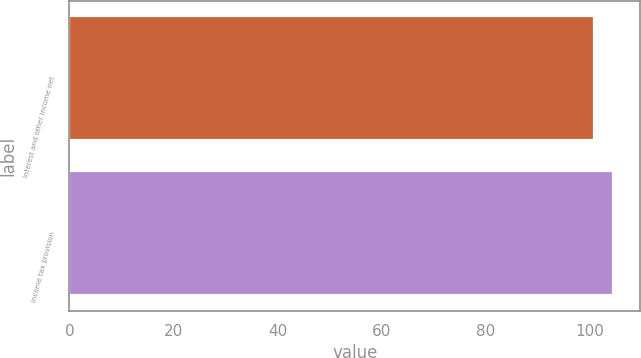Convert chart. <chart><loc_0><loc_0><loc_500><loc_500><bar_chart><fcel>Interest and other income net<fcel>Income tax provision<nl><fcel>100.7<fcel>104.4<nl></chart> 